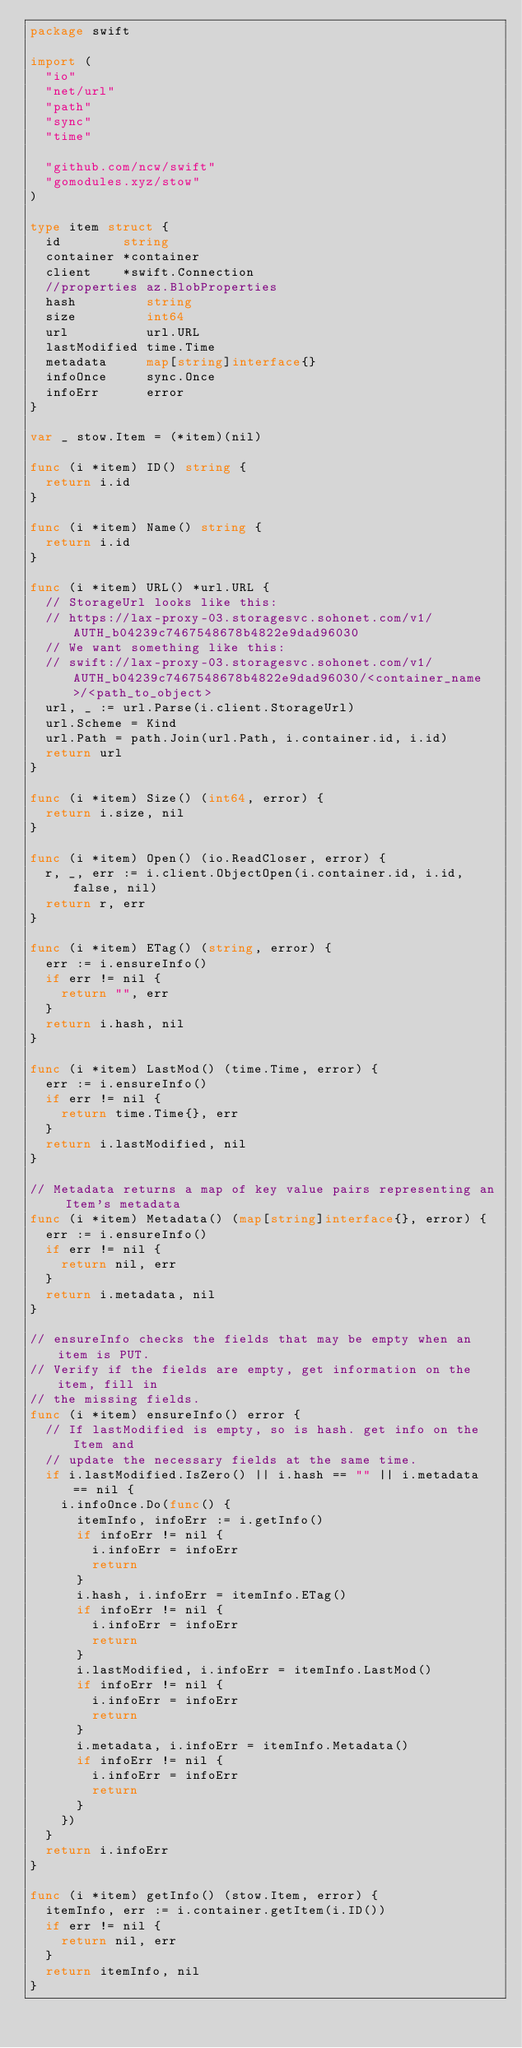Convert code to text. <code><loc_0><loc_0><loc_500><loc_500><_Go_>package swift

import (
	"io"
	"net/url"
	"path"
	"sync"
	"time"

	"github.com/ncw/swift"
	"gomodules.xyz/stow"
)

type item struct {
	id        string
	container *container
	client    *swift.Connection
	//properties az.BlobProperties
	hash         string
	size         int64
	url          url.URL
	lastModified time.Time
	metadata     map[string]interface{}
	infoOnce     sync.Once
	infoErr      error
}

var _ stow.Item = (*item)(nil)

func (i *item) ID() string {
	return i.id
}

func (i *item) Name() string {
	return i.id
}

func (i *item) URL() *url.URL {
	// StorageUrl looks like this:
	// https://lax-proxy-03.storagesvc.sohonet.com/v1/AUTH_b04239c7467548678b4822e9dad96030
	// We want something like this:
	// swift://lax-proxy-03.storagesvc.sohonet.com/v1/AUTH_b04239c7467548678b4822e9dad96030/<container_name>/<path_to_object>
	url, _ := url.Parse(i.client.StorageUrl)
	url.Scheme = Kind
	url.Path = path.Join(url.Path, i.container.id, i.id)
	return url
}

func (i *item) Size() (int64, error) {
	return i.size, nil
}

func (i *item) Open() (io.ReadCloser, error) {
	r, _, err := i.client.ObjectOpen(i.container.id, i.id, false, nil)
	return r, err
}

func (i *item) ETag() (string, error) {
	err := i.ensureInfo()
	if err != nil {
		return "", err
	}
	return i.hash, nil
}

func (i *item) LastMod() (time.Time, error) {
	err := i.ensureInfo()
	if err != nil {
		return time.Time{}, err
	}
	return i.lastModified, nil
}

// Metadata returns a map of key value pairs representing an Item's metadata
func (i *item) Metadata() (map[string]interface{}, error) {
	err := i.ensureInfo()
	if err != nil {
		return nil, err
	}
	return i.metadata, nil
}

// ensureInfo checks the fields that may be empty when an item is PUT.
// Verify if the fields are empty, get information on the item, fill in
// the missing fields.
func (i *item) ensureInfo() error {
	// If lastModified is empty, so is hash. get info on the Item and
	// update the necessary fields at the same time.
	if i.lastModified.IsZero() || i.hash == "" || i.metadata == nil {
		i.infoOnce.Do(func() {
			itemInfo, infoErr := i.getInfo()
			if infoErr != nil {
				i.infoErr = infoErr
				return
			}
			i.hash, i.infoErr = itemInfo.ETag()
			if infoErr != nil {
				i.infoErr = infoErr
				return
			}
			i.lastModified, i.infoErr = itemInfo.LastMod()
			if infoErr != nil {
				i.infoErr = infoErr
				return
			}
			i.metadata, i.infoErr = itemInfo.Metadata()
			if infoErr != nil {
				i.infoErr = infoErr
				return
			}
		})
	}
	return i.infoErr
}

func (i *item) getInfo() (stow.Item, error) {
	itemInfo, err := i.container.getItem(i.ID())
	if err != nil {
		return nil, err
	}
	return itemInfo, nil
}
</code> 